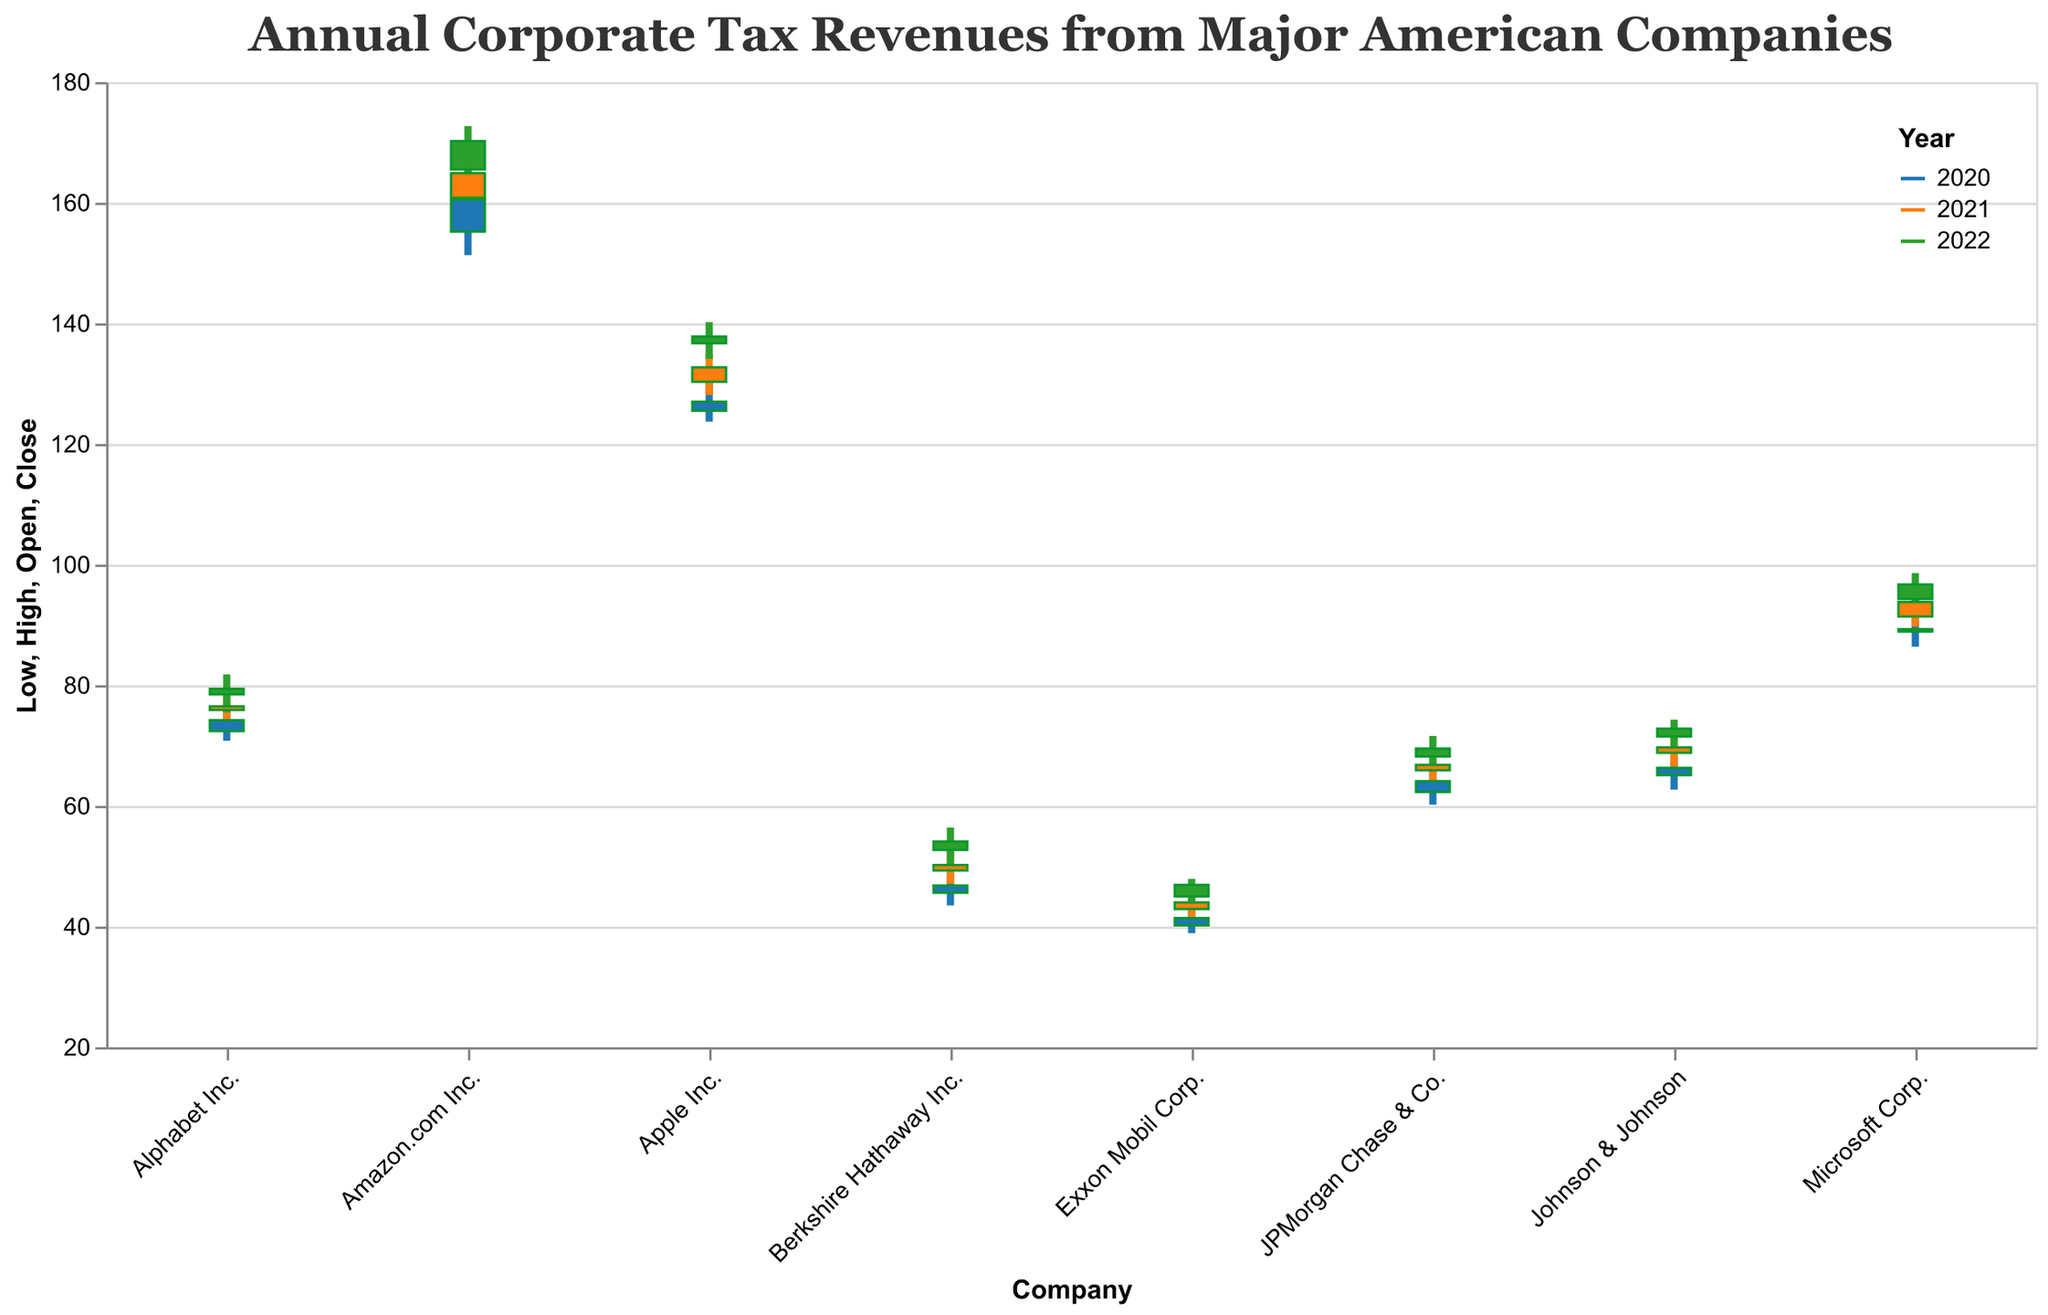Which company had the highest maximum tax revenue in 2022? Look at the "High" value for each company in 2022 and compare them. Amazon.com Inc. has the highest value of 172.7.
Answer: Amazon.com Inc How did Apple's tax revenue change from 2020 to 2021 in terms of the opening value? Compare the "Open" value for Apple Inc. in both years: 2020 had 125.5 and 2021 had 130.3. The difference is 130.3 - 125.5 = 4.8.
Answer: Increased by 4.8 In which year did JPMorgan Chase & Co. have the highest closing tax revenue? Look at the "Close" values for JPMorgan Chase & Co. for each year. 2022 has the highest value of 69.5.
Answer: 2022 What is the average closing tax revenue for Exxon Mobil Corp. over the three years shown? Add the "Close" values for 2020, 2021, and 2022, then divide by 3: (41.4 + 44.0 + 46.9) / 3 = 44.1.
Answer: 44.1 Which company's tax revenue has the smallest range (High - Low) in 2021? Calculate the range (High - Low) for each company in 2021 and find the smallest: Exxon Mobil Corp. has a range of 4.6 (45.4 - 40.8).
Answer: Exxon Mobil Corp For which company and year combination does the closing value exceed the opening value by the largest amount? Calculate the difference (Close - Open) for each company each year. Amazon.com Inc. in 2020 has the largest difference of 160.5 - 155.2 = 5.3.
Answer: Amazon.com Inc. in 2020 Did Johnson & Johnson's tax revenue show continuous growth in closing value from 2020 to 2022? Compare the "Close" values year-over-year: 2020 had 66.3, 2021 had 69.7, and 2022 had 72.8, showing continuous growth.
Answer: Yes How much more was Amazon.com Inc.'s closing value in 2022 compared to 2020? Subtract the 2020 closing value from the 2022 closing value: 170.2 - 160.5 = 9.7.
Answer: 9.7 Which sectors saw a decline in their closing tax revenue from 2021 to 2022? Compare the "Close" values between 2021 and 2022 for each company. Microsoft Corp., Alphabet Inc., and Berkshire Hathaway Inc. saw a decline.
Answer: Microsoft Corp., Alphabet Inc., Berkshire Hathaway Inc 